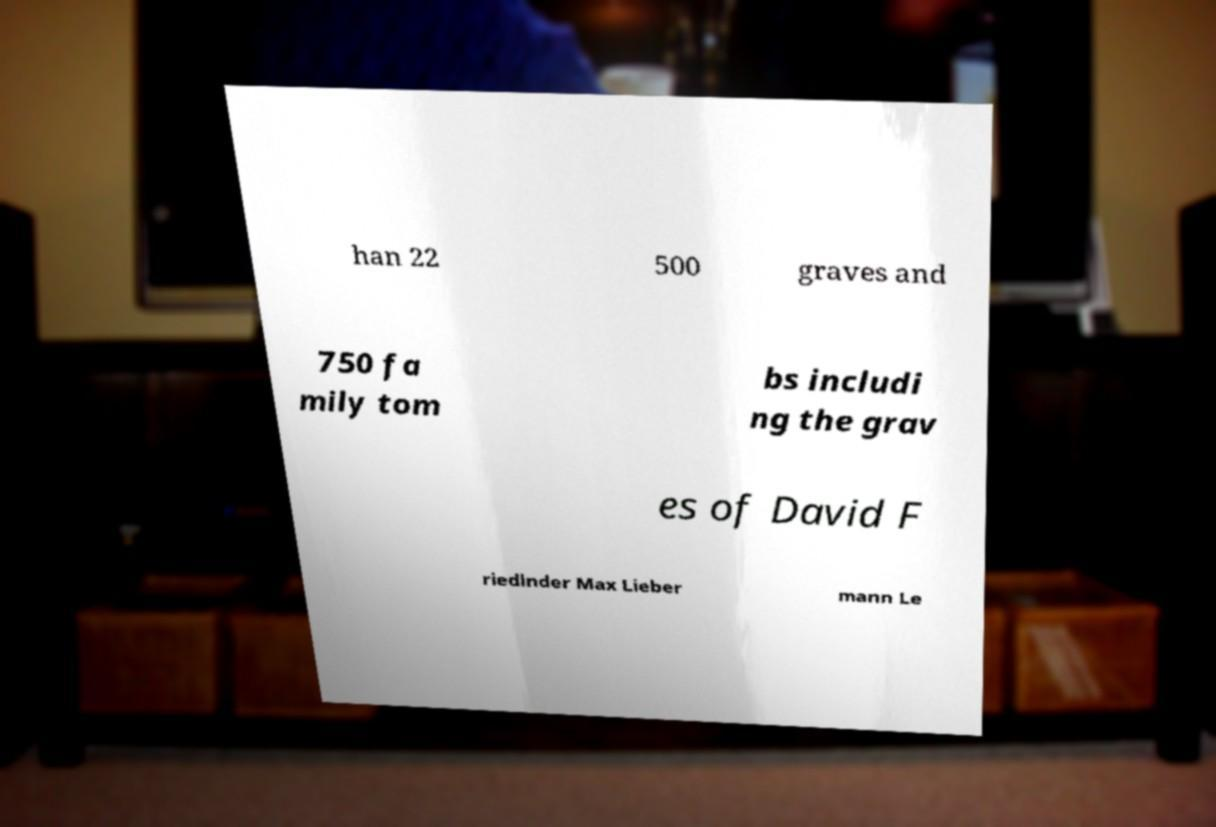Can you read and provide the text displayed in the image?This photo seems to have some interesting text. Can you extract and type it out for me? han 22 500 graves and 750 fa mily tom bs includi ng the grav es of David F riedlnder Max Lieber mann Le 